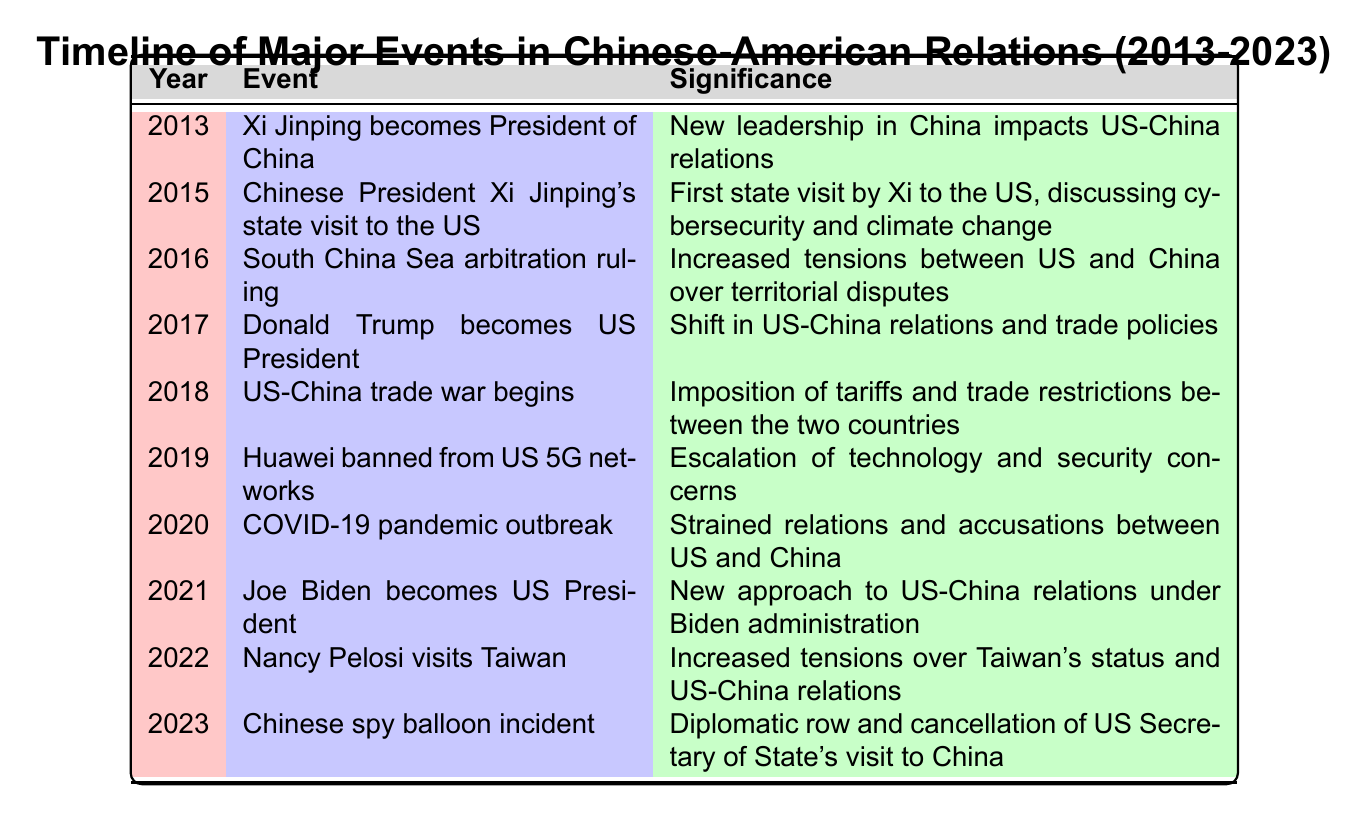What year did the US-China trade war begin? The table shows that the US-China trade war began in 2018. You can find this year listed alongside the corresponding event in the table.
Answer: 2018 Who was the US President during the Huawei ban from US 5G networks? The table states that Huawei was banned from US 5G networks in 2019, but it also indicates that Donald Trump became US President in 2017. Therefore, he was the President during the Huawei ban.
Answer: Donald Trump What significant event occurred in 2016 that increased tensions between the US and China? The table indicates that in 2016, there was a South China Sea arbitration ruling which was cited as a factor in increasing tensions between the two nations.
Answer: South China Sea arbitration ruling Was there a state visit by Xi Jinping to the US within this timeline? Yes, according to the table, Chinese President Xi Jinping made a state visit to the US in 2015. This visit was significant as it involved discussions on important issues like cybersecurity and climate change.
Answer: Yes Which event marks the beginning of Joe Biden's presidency in relation to Chinese-American relations? The table highlights that Joe Biden became US President in 2021, indicating a new approach to US-China relations under his administration. This marks the beginning of his presidency within the timeline provided.
Answer: Joe Biden becomes US President In how many years did significant events related to the Taiwan issue occur? The table indicates that significant events regarding Taiwan occurred in 2022 with Nancy Pelosi's visit to Taiwan. Thus, within this 10-year timeline, there was one significant event related to Taiwan.
Answer: 1 What was the significance of the 2020 COVID-19 pandemic outbreak in US-China relations? The table indicates that the COVID-19 pandemic outbreak in 2020 strained relations between the US and China, resulting in mutual accusations. This highlights the tensions caused by the pandemic.
Answer: Strained relations and accusations What was the order of the events from 2015 to 2020 that affected US-China relations? The events from 2015 to 2020 in order are: Xi Jinping's state visit to the US (2015), South China Sea arbitration ruling (2016), Donald Trump becomes US President (2017), US-China trade war begins (2018), and COVID-19 pandemic outbreak (2020).
Answer: Xi Jinping's state visit, South China Sea ruling, Trump presidency, trade war, COVID-19 pandemic Was there any incident reported in 2023 related to diplomacy between the US and China? Yes, the table notes a Chinese spy balloon incident in 2023, which led to a diplomatic row and the cancellation of the US Secretary of State's visit to China, indicating a significant diplomatic issue that year.
Answer: Yes 